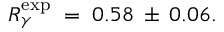<formula> <loc_0><loc_0><loc_500><loc_500>R _ { \gamma } ^ { \exp } \, = \, 0 . 5 8 \, \pm \, 0 . 0 6 .</formula> 